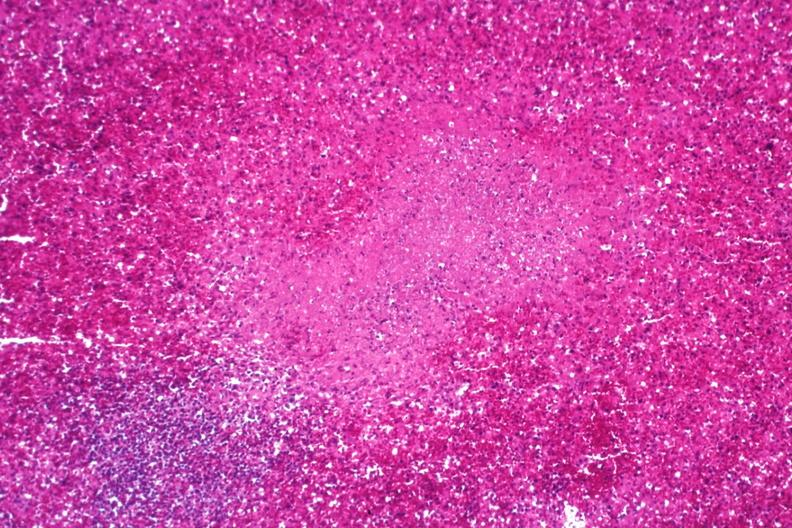what is present?
Answer the question using a single word or phrase. Spleen 